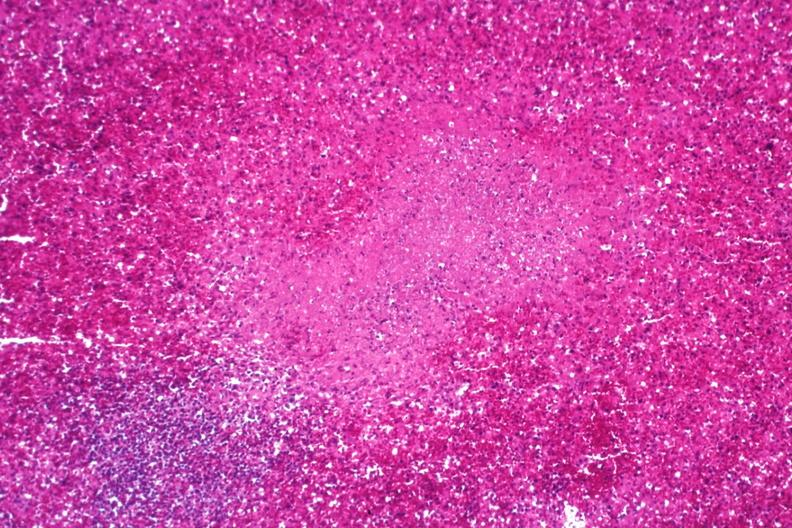what is present?
Answer the question using a single word or phrase. Spleen 